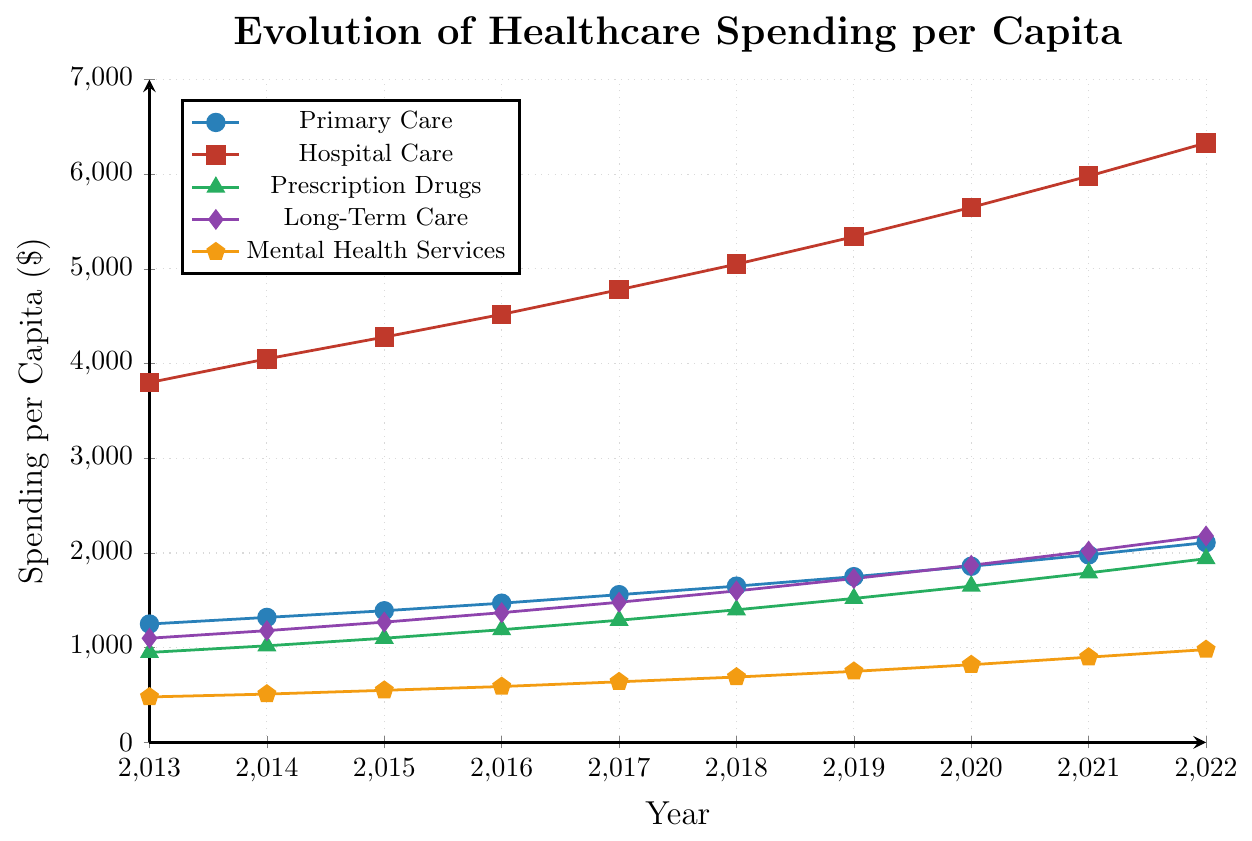Which category of healthcare spending had the highest increase in absolute terms from 2013 to 2022? To calculate the absolute increase for each category, subtract the 2013 value from the 2022 value. Primary Care: 2110 - 1250 = 860, Hospital Care: 6330 - 3800 = 2530, Prescription Drugs: 1940 - 950 = 990, Long-Term Care: 2180 - 1100 = 1080, Mental Health Services: 980 - 480 = 500. Hospital Care had the highest increase.
Answer: Hospital Care Which year saw the highest spending on Prescription Drugs? Refer to the data points marked with a green triangle representing Prescription Drugs. The highest value is in 2022.
Answer: 2022 What is the total spending per capita on Primary Care and Mental Health Services in 2018? Add the 2018 values for Primary Care and Mental Health Services. Primary Care: 1650, Mental Health Services: 690. Total = 1650 + 690 = 2340.
Answer: 2340 In which year did spending on Long-Term Care surpass 2000 per capita? Identify when the purple diamond representing Long-Term Care exceeds 2000. This happens in 2021 with a value of 2020.
Answer: 2021 What is the average annual increase in spending for Primary Care from 2017 to 2022? Compute the increase between 2017 and 2022, then divide by the number of years. Primary Care in 2022: 2110, in 2017: 1560. Increase is 2110 - 1560 = 550. Number of years = 2022 - 2017 = 5. Average annual increase = 550 / 5 = 110.
Answer: 110 Which category experienced the smallest increase in spending from 2013 to 2022? Compute the increase for each category and compare. Primary Care: 860, Hospital Care: 2530, Prescription Drugs: 990, Long-Term Care: 1080, Mental Health Services: 500. Mental Health Services had the smallest increase.
Answer: Mental Health Services By how much did Hospital Care spending exceed Prescription Drugs spending in 2020? Subtract the Prescription Drugs value in 2020 from the Hospital Care value in 2020. Hospital Care: 5650, Prescription Drugs: 1650. Difference = 5650 - 1650 = 4000.
Answer: 4000 Which category showed the steadiest increase in spending over the years? Visually inspect the trend lines for each category for smoothness and consistency of increase. Primary Care shows a steady and consistent increase.
Answer: Primary Care What is the combined spending on Hospital Care and Long-Term Care in 2019? Add the 2019 values for Hospital Care and Long-Term Care. Hospital Care: 5340, Long-Term Care: 1730. Total = 5340 + 1730 = 7070.
Answer: 7070 